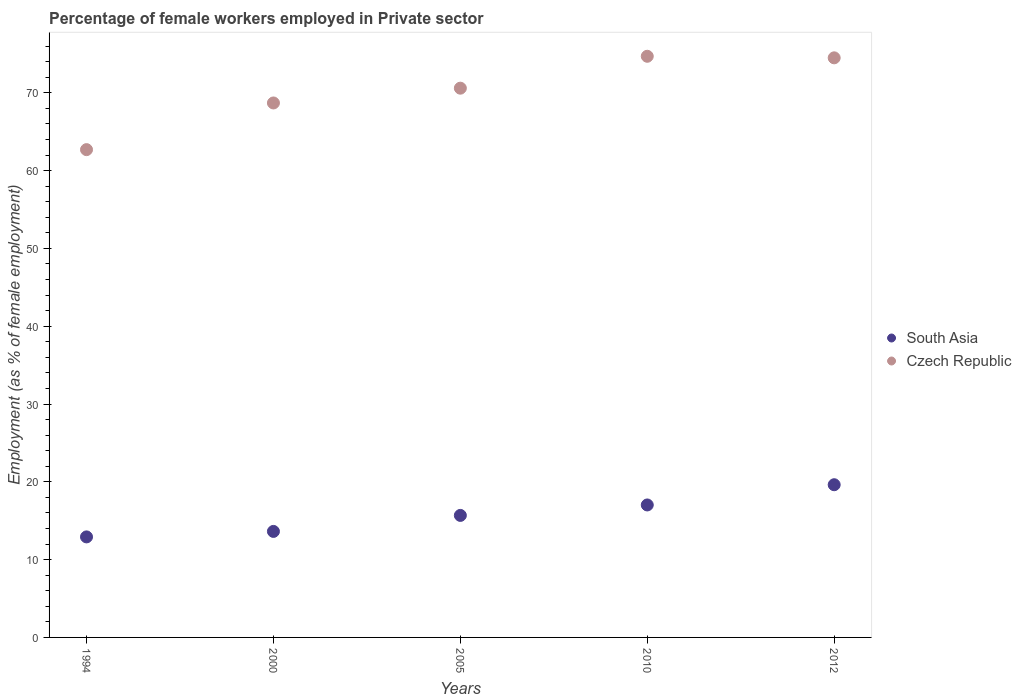Is the number of dotlines equal to the number of legend labels?
Offer a terse response. Yes. What is the percentage of females employed in Private sector in Czech Republic in 2010?
Provide a succinct answer. 74.7. Across all years, what is the maximum percentage of females employed in Private sector in Czech Republic?
Your answer should be compact. 74.7. Across all years, what is the minimum percentage of females employed in Private sector in South Asia?
Make the answer very short. 12.92. In which year was the percentage of females employed in Private sector in South Asia maximum?
Offer a very short reply. 2012. What is the total percentage of females employed in Private sector in South Asia in the graph?
Make the answer very short. 78.89. What is the difference between the percentage of females employed in Private sector in Czech Republic in 1994 and that in 2012?
Keep it short and to the point. -11.8. What is the difference between the percentage of females employed in Private sector in Czech Republic in 1994 and the percentage of females employed in Private sector in South Asia in 2000?
Ensure brevity in your answer.  49.07. What is the average percentage of females employed in Private sector in South Asia per year?
Offer a terse response. 15.78. In the year 2010, what is the difference between the percentage of females employed in Private sector in South Asia and percentage of females employed in Private sector in Czech Republic?
Give a very brief answer. -57.67. What is the ratio of the percentage of females employed in Private sector in South Asia in 2000 to that in 2005?
Provide a short and direct response. 0.87. Is the percentage of females employed in Private sector in South Asia in 2005 less than that in 2012?
Provide a short and direct response. Yes. What is the difference between the highest and the second highest percentage of females employed in Private sector in Czech Republic?
Ensure brevity in your answer.  0.2. What is the difference between the highest and the lowest percentage of females employed in Private sector in South Asia?
Ensure brevity in your answer.  6.71. In how many years, is the percentage of females employed in Private sector in Czech Republic greater than the average percentage of females employed in Private sector in Czech Republic taken over all years?
Offer a very short reply. 3. How many years are there in the graph?
Make the answer very short. 5. Does the graph contain any zero values?
Your answer should be compact. No. Where does the legend appear in the graph?
Ensure brevity in your answer.  Center right. What is the title of the graph?
Keep it short and to the point. Percentage of female workers employed in Private sector. Does "Gabon" appear as one of the legend labels in the graph?
Your answer should be very brief. No. What is the label or title of the X-axis?
Provide a succinct answer. Years. What is the label or title of the Y-axis?
Provide a succinct answer. Employment (as % of female employment). What is the Employment (as % of female employment) of South Asia in 1994?
Keep it short and to the point. 12.92. What is the Employment (as % of female employment) of Czech Republic in 1994?
Provide a short and direct response. 62.7. What is the Employment (as % of female employment) of South Asia in 2000?
Your answer should be compact. 13.63. What is the Employment (as % of female employment) in Czech Republic in 2000?
Your answer should be compact. 68.7. What is the Employment (as % of female employment) in South Asia in 2005?
Your answer should be compact. 15.68. What is the Employment (as % of female employment) in Czech Republic in 2005?
Your answer should be very brief. 70.6. What is the Employment (as % of female employment) of South Asia in 2010?
Your answer should be very brief. 17.03. What is the Employment (as % of female employment) of Czech Republic in 2010?
Make the answer very short. 74.7. What is the Employment (as % of female employment) in South Asia in 2012?
Your answer should be very brief. 19.63. What is the Employment (as % of female employment) of Czech Republic in 2012?
Ensure brevity in your answer.  74.5. Across all years, what is the maximum Employment (as % of female employment) of South Asia?
Make the answer very short. 19.63. Across all years, what is the maximum Employment (as % of female employment) of Czech Republic?
Make the answer very short. 74.7. Across all years, what is the minimum Employment (as % of female employment) of South Asia?
Offer a terse response. 12.92. Across all years, what is the minimum Employment (as % of female employment) of Czech Republic?
Give a very brief answer. 62.7. What is the total Employment (as % of female employment) of South Asia in the graph?
Provide a short and direct response. 78.89. What is the total Employment (as % of female employment) in Czech Republic in the graph?
Keep it short and to the point. 351.2. What is the difference between the Employment (as % of female employment) in South Asia in 1994 and that in 2000?
Ensure brevity in your answer.  -0.71. What is the difference between the Employment (as % of female employment) of South Asia in 1994 and that in 2005?
Offer a very short reply. -2.76. What is the difference between the Employment (as % of female employment) of South Asia in 1994 and that in 2010?
Offer a terse response. -4.11. What is the difference between the Employment (as % of female employment) of Czech Republic in 1994 and that in 2010?
Offer a very short reply. -12. What is the difference between the Employment (as % of female employment) in South Asia in 1994 and that in 2012?
Your answer should be compact. -6.71. What is the difference between the Employment (as % of female employment) in South Asia in 2000 and that in 2005?
Give a very brief answer. -2.06. What is the difference between the Employment (as % of female employment) in South Asia in 2000 and that in 2010?
Your answer should be very brief. -3.4. What is the difference between the Employment (as % of female employment) of South Asia in 2000 and that in 2012?
Provide a succinct answer. -6. What is the difference between the Employment (as % of female employment) in Czech Republic in 2000 and that in 2012?
Keep it short and to the point. -5.8. What is the difference between the Employment (as % of female employment) in South Asia in 2005 and that in 2010?
Your answer should be compact. -1.34. What is the difference between the Employment (as % of female employment) in South Asia in 2005 and that in 2012?
Provide a short and direct response. -3.94. What is the difference between the Employment (as % of female employment) in South Asia in 2010 and that in 2012?
Provide a short and direct response. -2.6. What is the difference between the Employment (as % of female employment) in Czech Republic in 2010 and that in 2012?
Make the answer very short. 0.2. What is the difference between the Employment (as % of female employment) in South Asia in 1994 and the Employment (as % of female employment) in Czech Republic in 2000?
Your answer should be compact. -55.78. What is the difference between the Employment (as % of female employment) of South Asia in 1994 and the Employment (as % of female employment) of Czech Republic in 2005?
Offer a very short reply. -57.68. What is the difference between the Employment (as % of female employment) in South Asia in 1994 and the Employment (as % of female employment) in Czech Republic in 2010?
Your answer should be compact. -61.78. What is the difference between the Employment (as % of female employment) in South Asia in 1994 and the Employment (as % of female employment) in Czech Republic in 2012?
Your answer should be compact. -61.58. What is the difference between the Employment (as % of female employment) of South Asia in 2000 and the Employment (as % of female employment) of Czech Republic in 2005?
Offer a very short reply. -56.97. What is the difference between the Employment (as % of female employment) in South Asia in 2000 and the Employment (as % of female employment) in Czech Republic in 2010?
Your answer should be very brief. -61.07. What is the difference between the Employment (as % of female employment) of South Asia in 2000 and the Employment (as % of female employment) of Czech Republic in 2012?
Provide a short and direct response. -60.87. What is the difference between the Employment (as % of female employment) of South Asia in 2005 and the Employment (as % of female employment) of Czech Republic in 2010?
Keep it short and to the point. -59.02. What is the difference between the Employment (as % of female employment) in South Asia in 2005 and the Employment (as % of female employment) in Czech Republic in 2012?
Make the answer very short. -58.82. What is the difference between the Employment (as % of female employment) in South Asia in 2010 and the Employment (as % of female employment) in Czech Republic in 2012?
Make the answer very short. -57.47. What is the average Employment (as % of female employment) in South Asia per year?
Ensure brevity in your answer.  15.78. What is the average Employment (as % of female employment) of Czech Republic per year?
Provide a succinct answer. 70.24. In the year 1994, what is the difference between the Employment (as % of female employment) of South Asia and Employment (as % of female employment) of Czech Republic?
Offer a terse response. -49.78. In the year 2000, what is the difference between the Employment (as % of female employment) in South Asia and Employment (as % of female employment) in Czech Republic?
Your response must be concise. -55.07. In the year 2005, what is the difference between the Employment (as % of female employment) in South Asia and Employment (as % of female employment) in Czech Republic?
Keep it short and to the point. -54.92. In the year 2010, what is the difference between the Employment (as % of female employment) of South Asia and Employment (as % of female employment) of Czech Republic?
Ensure brevity in your answer.  -57.67. In the year 2012, what is the difference between the Employment (as % of female employment) of South Asia and Employment (as % of female employment) of Czech Republic?
Offer a terse response. -54.87. What is the ratio of the Employment (as % of female employment) in South Asia in 1994 to that in 2000?
Give a very brief answer. 0.95. What is the ratio of the Employment (as % of female employment) of Czech Republic in 1994 to that in 2000?
Give a very brief answer. 0.91. What is the ratio of the Employment (as % of female employment) of South Asia in 1994 to that in 2005?
Your answer should be very brief. 0.82. What is the ratio of the Employment (as % of female employment) of Czech Republic in 1994 to that in 2005?
Give a very brief answer. 0.89. What is the ratio of the Employment (as % of female employment) of South Asia in 1994 to that in 2010?
Offer a terse response. 0.76. What is the ratio of the Employment (as % of female employment) of Czech Republic in 1994 to that in 2010?
Give a very brief answer. 0.84. What is the ratio of the Employment (as % of female employment) in South Asia in 1994 to that in 2012?
Provide a succinct answer. 0.66. What is the ratio of the Employment (as % of female employment) in Czech Republic in 1994 to that in 2012?
Your answer should be very brief. 0.84. What is the ratio of the Employment (as % of female employment) of South Asia in 2000 to that in 2005?
Your response must be concise. 0.87. What is the ratio of the Employment (as % of female employment) of Czech Republic in 2000 to that in 2005?
Your response must be concise. 0.97. What is the ratio of the Employment (as % of female employment) of South Asia in 2000 to that in 2010?
Offer a very short reply. 0.8. What is the ratio of the Employment (as % of female employment) of Czech Republic in 2000 to that in 2010?
Offer a terse response. 0.92. What is the ratio of the Employment (as % of female employment) in South Asia in 2000 to that in 2012?
Your response must be concise. 0.69. What is the ratio of the Employment (as % of female employment) in Czech Republic in 2000 to that in 2012?
Keep it short and to the point. 0.92. What is the ratio of the Employment (as % of female employment) in South Asia in 2005 to that in 2010?
Your answer should be compact. 0.92. What is the ratio of the Employment (as % of female employment) of Czech Republic in 2005 to that in 2010?
Make the answer very short. 0.95. What is the ratio of the Employment (as % of female employment) of South Asia in 2005 to that in 2012?
Your answer should be very brief. 0.8. What is the ratio of the Employment (as % of female employment) of Czech Republic in 2005 to that in 2012?
Keep it short and to the point. 0.95. What is the ratio of the Employment (as % of female employment) in South Asia in 2010 to that in 2012?
Your answer should be compact. 0.87. What is the difference between the highest and the second highest Employment (as % of female employment) in South Asia?
Ensure brevity in your answer.  2.6. What is the difference between the highest and the lowest Employment (as % of female employment) of South Asia?
Give a very brief answer. 6.71. 